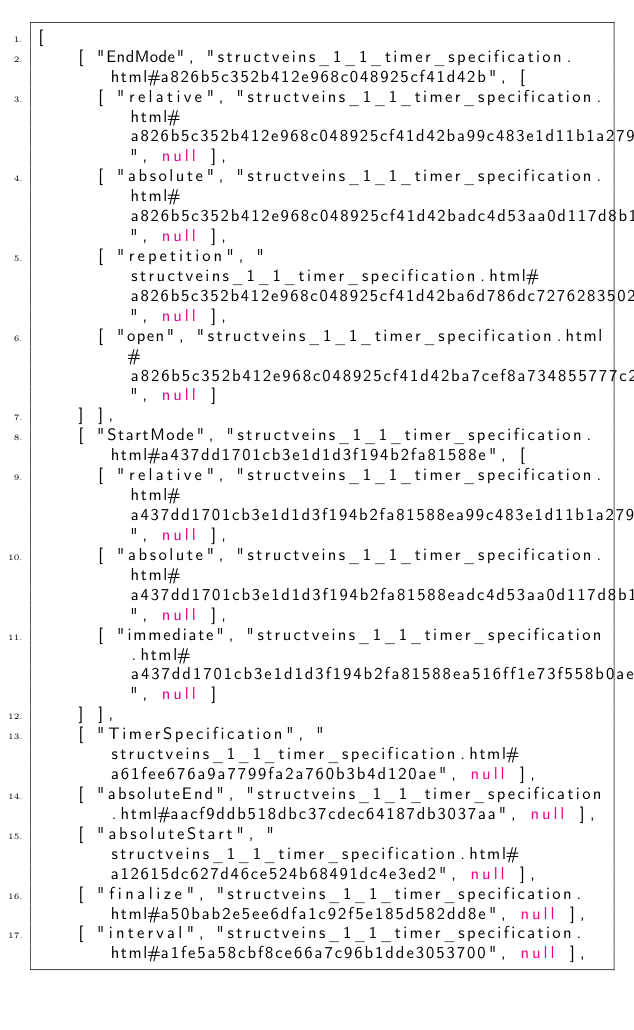Convert code to text. <code><loc_0><loc_0><loc_500><loc_500><_JavaScript_>[
    [ "EndMode", "structveins_1_1_timer_specification.html#a826b5c352b412e968c048925cf41d42b", [
      [ "relative", "structveins_1_1_timer_specification.html#a826b5c352b412e968c048925cf41d42ba99c483e1d11b1a279a2a1a3960528487", null ],
      [ "absolute", "structveins_1_1_timer_specification.html#a826b5c352b412e968c048925cf41d42badc4d53aa0d117d8b189b36d161af4e96", null ],
      [ "repetition", "structveins_1_1_timer_specification.html#a826b5c352b412e968c048925cf41d42ba6d786dc72762835027312be990412a9e", null ],
      [ "open", "structveins_1_1_timer_specification.html#a826b5c352b412e968c048925cf41d42ba7cef8a734855777c2a9d0caf42666e69", null ]
    ] ],
    [ "StartMode", "structveins_1_1_timer_specification.html#a437dd1701cb3e1d1d3f194b2fa81588e", [
      [ "relative", "structveins_1_1_timer_specification.html#a437dd1701cb3e1d1d3f194b2fa81588ea99c483e1d11b1a279a2a1a3960528487", null ],
      [ "absolute", "structveins_1_1_timer_specification.html#a437dd1701cb3e1d1d3f194b2fa81588eadc4d53aa0d117d8b189b36d161af4e96", null ],
      [ "immediate", "structveins_1_1_timer_specification.html#a437dd1701cb3e1d1d3f194b2fa81588ea516ff1e73f558b0ae701ae4561a63e2c", null ]
    ] ],
    [ "TimerSpecification", "structveins_1_1_timer_specification.html#a61fee676a9a7799fa2a760b3b4d120ae", null ],
    [ "absoluteEnd", "structveins_1_1_timer_specification.html#aacf9ddb518dbc37cdec64187db3037aa", null ],
    [ "absoluteStart", "structveins_1_1_timer_specification.html#a12615dc627d46ce524b68491dc4e3ed2", null ],
    [ "finalize", "structveins_1_1_timer_specification.html#a50bab2e5ee6dfa1c92f5e185d582dd8e", null ],
    [ "interval", "structveins_1_1_timer_specification.html#a1fe5a58cbf8ce66a7c96b1dde3053700", null ],</code> 